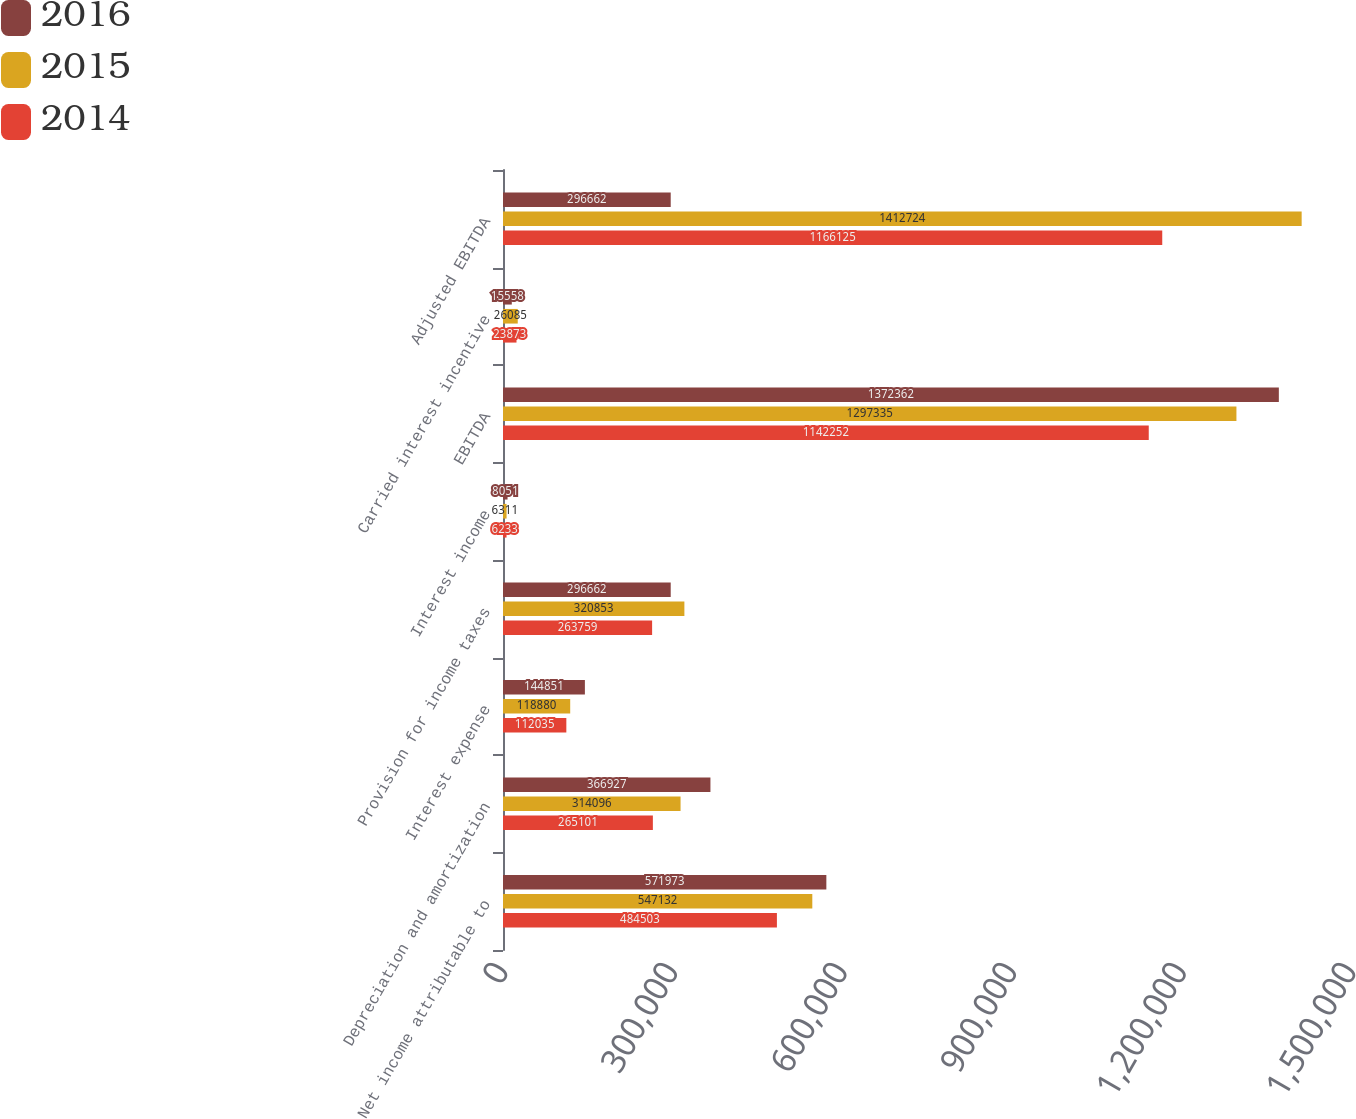Convert chart to OTSL. <chart><loc_0><loc_0><loc_500><loc_500><stacked_bar_chart><ecel><fcel>Net income attributable to<fcel>Depreciation and amortization<fcel>Interest expense<fcel>Provision for income taxes<fcel>Interest income<fcel>EBITDA<fcel>Carried interest incentive<fcel>Adjusted EBITDA<nl><fcel>2016<fcel>571973<fcel>366927<fcel>144851<fcel>296662<fcel>8051<fcel>1.37236e+06<fcel>15558<fcel>296662<nl><fcel>2015<fcel>547132<fcel>314096<fcel>118880<fcel>320853<fcel>6311<fcel>1.29734e+06<fcel>26085<fcel>1.41272e+06<nl><fcel>2014<fcel>484503<fcel>265101<fcel>112035<fcel>263759<fcel>6233<fcel>1.14225e+06<fcel>23873<fcel>1.16612e+06<nl></chart> 